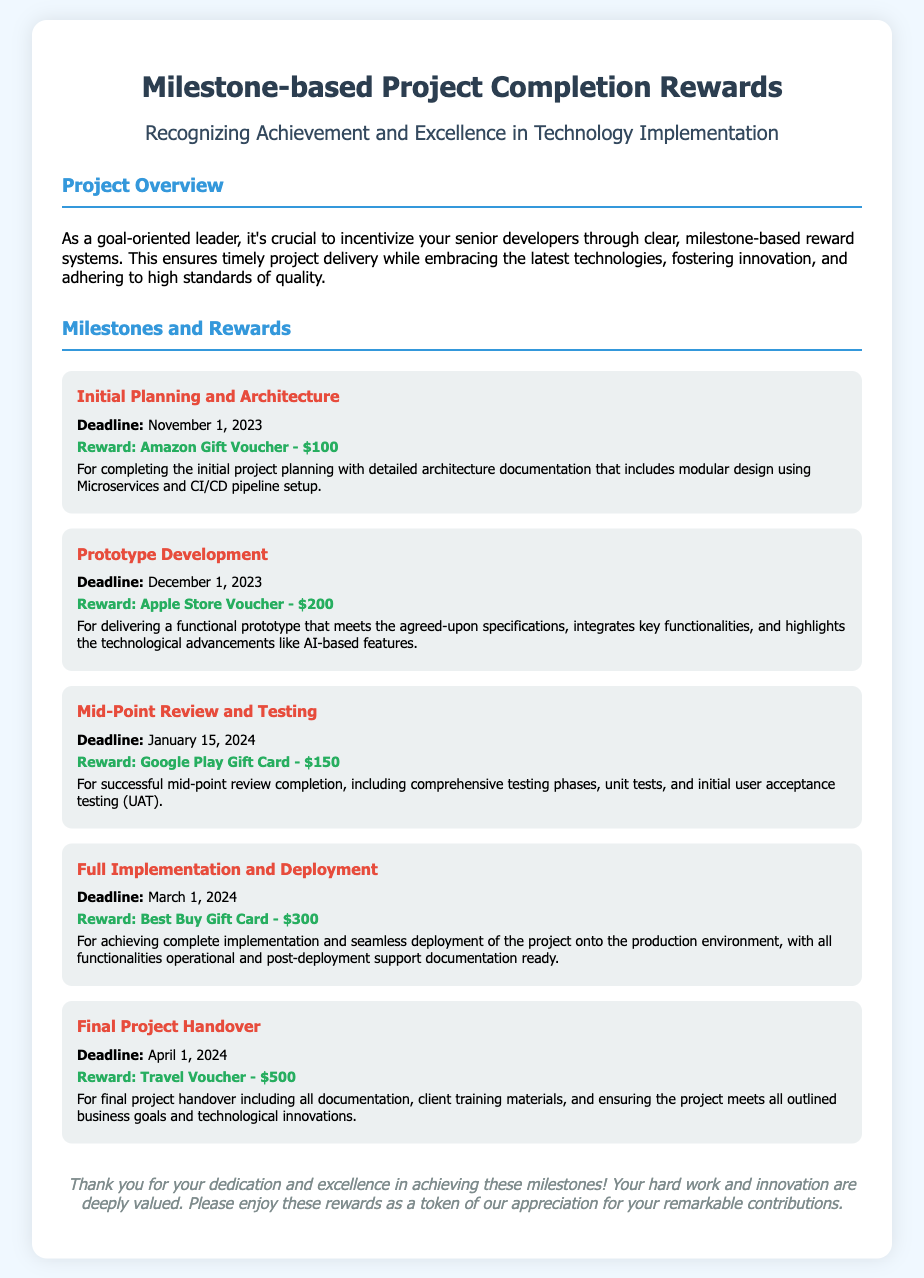What is the reward for Initial Planning and Architecture? The document specifies a reward of an Amazon Gift Voucher for this milestone.
Answer: Amazon Gift Voucher - $100 What is the deadline for Prototype Development? The document indicates that the deadline for this milestone is December 1, 2023.
Answer: December 1, 2023 How much is the reward for the Full Implementation and Deployment milestone? The document states that the reward for this milestone is a Best Buy Gift Card.
Answer: Best Buy Gift Card - $300 What is the primary aim of the Milestone-based Project Completion Rewards? The document describes the aim as incentivizing senior developers and ensuring timely project delivery.
Answer: Incentivizing senior developers What is mentioned about user acceptance testing in the Mid-Point Review and Testing section? The document mentions that this milestone includes initial user acceptance testing (UAT).
Answer: Initial user acceptance testing What is the highest valued reward listed in the document? The document states that the highest valued reward is $500 for the Final Project Handover.
Answer: Travel Voucher - $500 What initiative is recognized through the project overview section? The project overview acknowledges achievement and excellence in technology implementation.
Answer: Achievement and excellence What does the project aim to foster according to the overview? The project aims to foster innovation as outlined in the document.
Answer: Innovation How many milestones are detailed in the document? The document details five separate milestones related to project completion.
Answer: Five milestones 